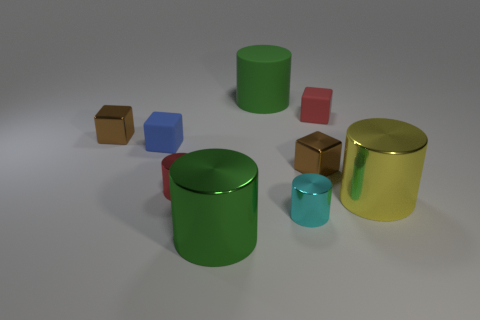Are there more small objects that are in front of the yellow cylinder than green cylinders right of the red matte cube?
Ensure brevity in your answer.  Yes. Is the size of the green metallic cylinder the same as the yellow metal cylinder?
Your response must be concise. Yes. What color is the matte object that is the same shape as the red metallic object?
Provide a succinct answer. Green. What number of things are the same color as the matte cylinder?
Make the answer very short. 1. Are there more big metallic things that are left of the red cube than green spheres?
Give a very brief answer. Yes. The tiny cylinder in front of the large yellow shiny cylinder that is right of the small cyan shiny cylinder is what color?
Your answer should be compact. Cyan. How many things are either green objects in front of the large yellow metallic cylinder or rubber things that are to the left of the red rubber cube?
Offer a very short reply. 3. The rubber cylinder has what color?
Make the answer very short. Green. How many large objects have the same material as the small cyan thing?
Make the answer very short. 2. Are there more gray metallic things than shiny cylinders?
Offer a very short reply. No. 